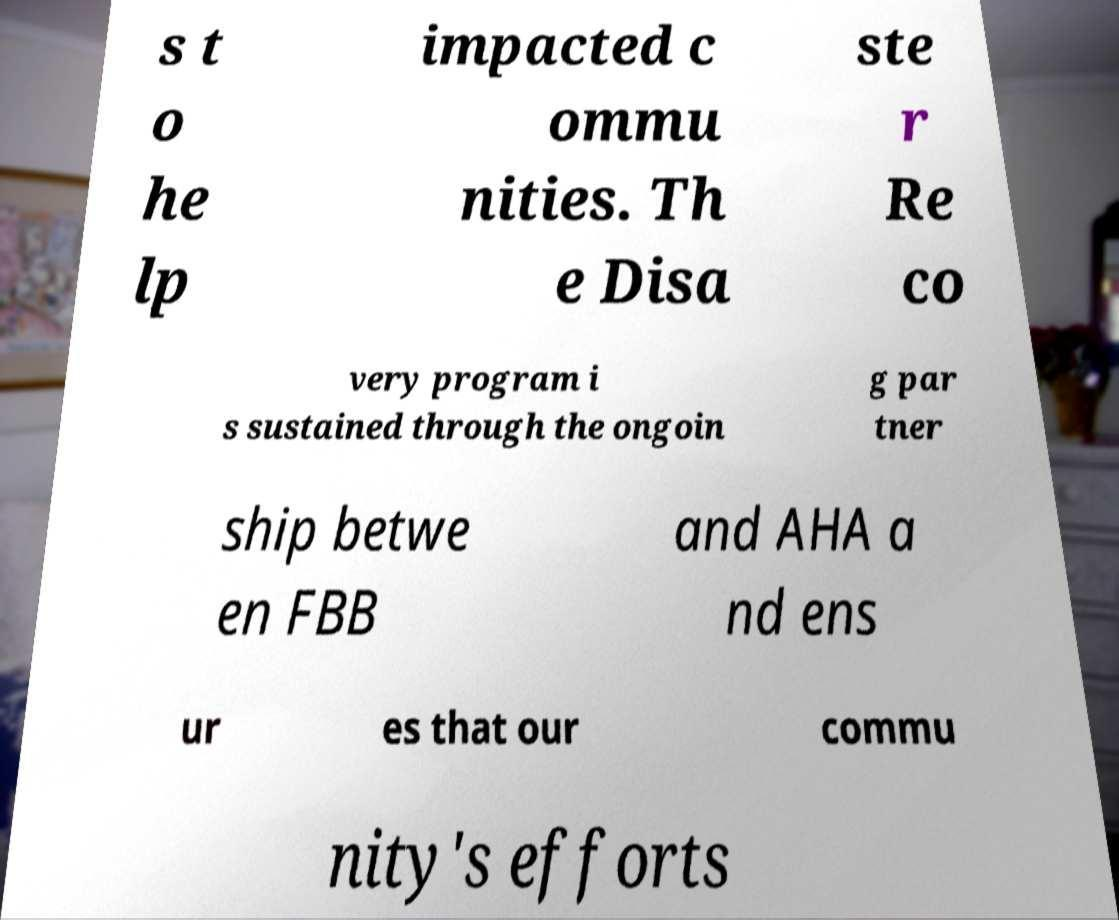Can you read and provide the text displayed in the image?This photo seems to have some interesting text. Can you extract and type it out for me? s t o he lp impacted c ommu nities. Th e Disa ste r Re co very program i s sustained through the ongoin g par tner ship betwe en FBB and AHA a nd ens ur es that our commu nity's efforts 